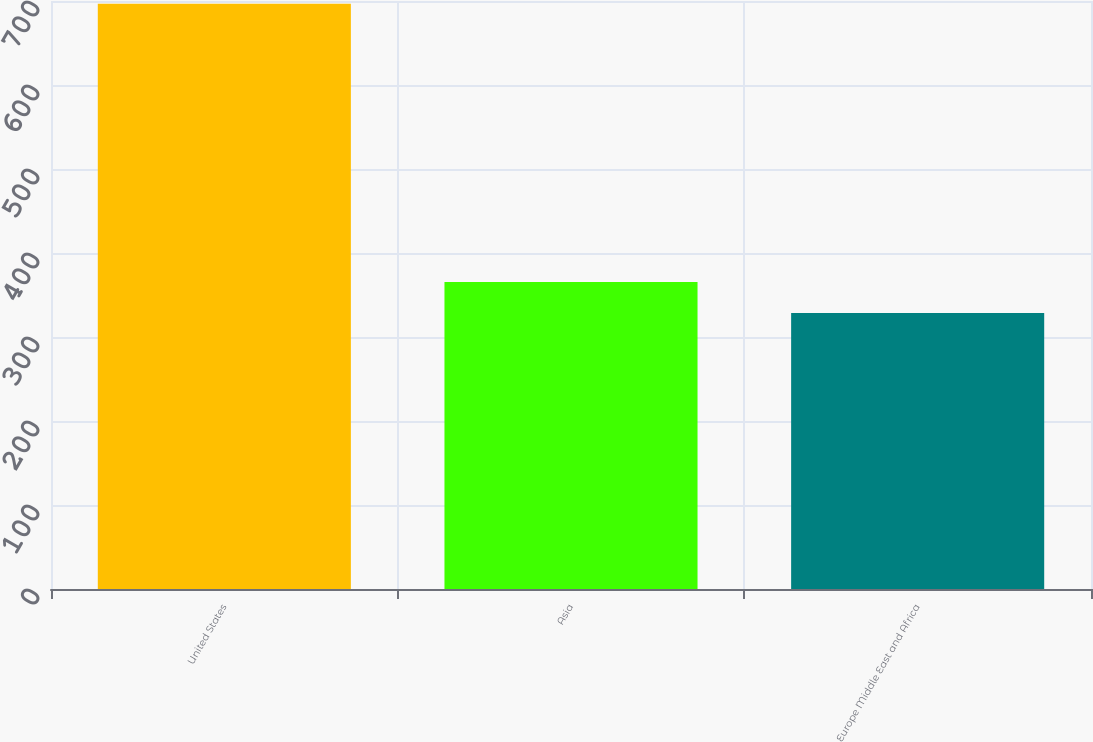<chart> <loc_0><loc_0><loc_500><loc_500><bar_chart><fcel>United States<fcel>Asia<fcel>Europe Middle East and Africa<nl><fcel>696.6<fcel>365.49<fcel>328.7<nl></chart> 